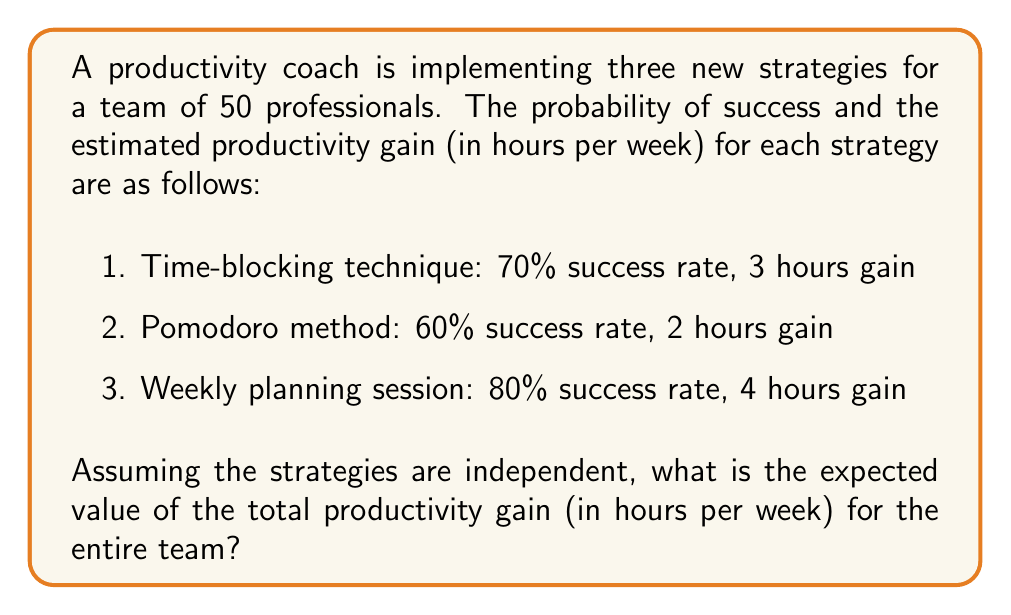Help me with this question. To solve this problem, we need to calculate the expected value of productivity gains for each strategy and then sum them up for the entire team. Let's break it down step-by-step:

1. Calculate the expected value for each strategy:

   a. Time-blocking technique:
      $E_1 = P(\text{success}) \times \text{Gain} = 0.70 \times 3 = 2.1$ hours

   b. Pomodoro method:
      $E_2 = P(\text{success}) \times \text{Gain} = 0.60 \times 2 = 1.2$ hours

   c. Weekly planning session:
      $E_3 = P(\text{success}) \times \text{Gain} = 0.80 \times 4 = 3.2$ hours

2. Sum up the expected values for all strategies:
   $E_{\text{total}} = E_1 + E_2 + E_3 = 2.1 + 1.2 + 3.2 = 6.5$ hours

3. Multiply the total expected value by the number of team members:
   $E_{\text{team}} = E_{\text{total}} \times \text{Team size} = 6.5 \times 50 = 325$ hours

Therefore, the expected value of the total productivity gain for the entire team is 325 hours per week.
Answer: 325 hours per week 